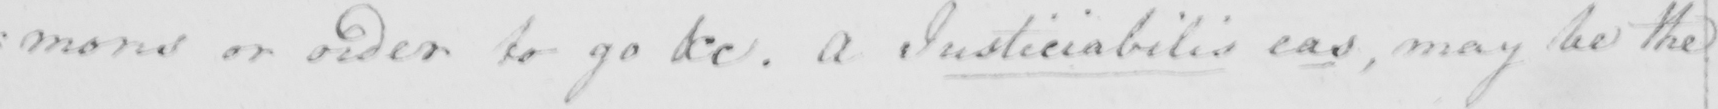Can you read and transcribe this handwriting? mons or order to go &c . A Justiciabilis eas , may be the 